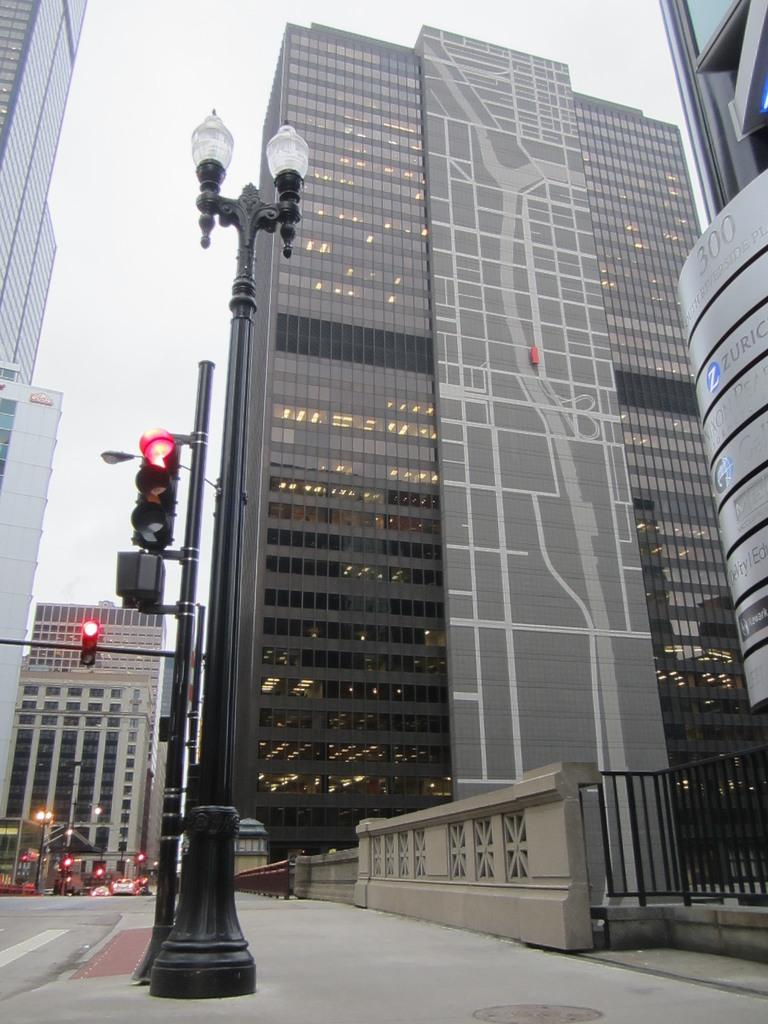What objects in the image? There are poles and traffic signals in the image. What is the primary function of the poles and traffic signals? The poles and traffic signals are likely used for regulating traffic on the road. What can be seen on the road in the image? Vehicles are moving on the road in the image. What is visible in the background of the image? There are buildings and the clear sky visible in the background of the image. Can you tell me how many visitors are wearing a vest in the image? There are no visitors present in the image, and therefore no one is wearing a vest. What type of view can be seen from the top of the poles in the image? The image does not provide a view from the top of the poles, as it is a photograph taken from ground level. 